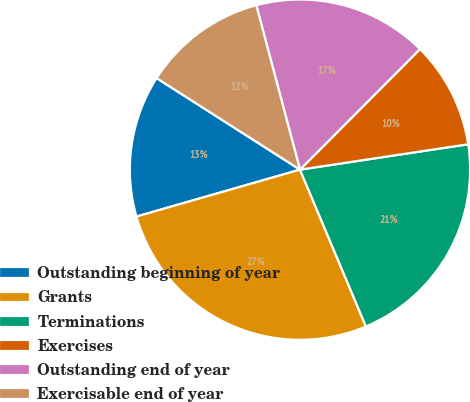Convert chart to OTSL. <chart><loc_0><loc_0><loc_500><loc_500><pie_chart><fcel>Outstanding beginning of year<fcel>Grants<fcel>Terminations<fcel>Exercises<fcel>Outstanding end of year<fcel>Exercisable end of year<nl><fcel>13.49%<fcel>26.89%<fcel>21.05%<fcel>10.15%<fcel>16.6%<fcel>11.82%<nl></chart> 